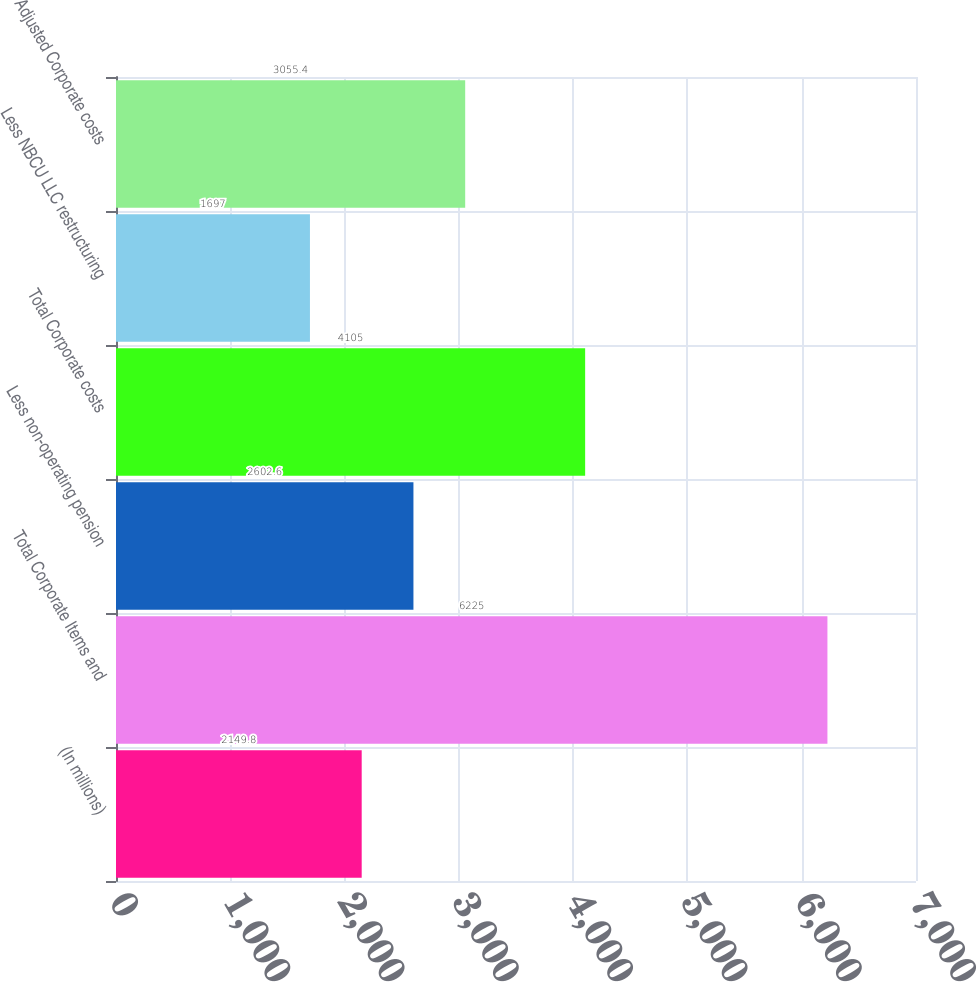Convert chart to OTSL. <chart><loc_0><loc_0><loc_500><loc_500><bar_chart><fcel>(In millions)<fcel>Total Corporate Items and<fcel>Less non-operating pension<fcel>Total Corporate costs<fcel>Less NBCU LLC restructuring<fcel>Adjusted Corporate costs<nl><fcel>2149.8<fcel>6225<fcel>2602.6<fcel>4105<fcel>1697<fcel>3055.4<nl></chart> 